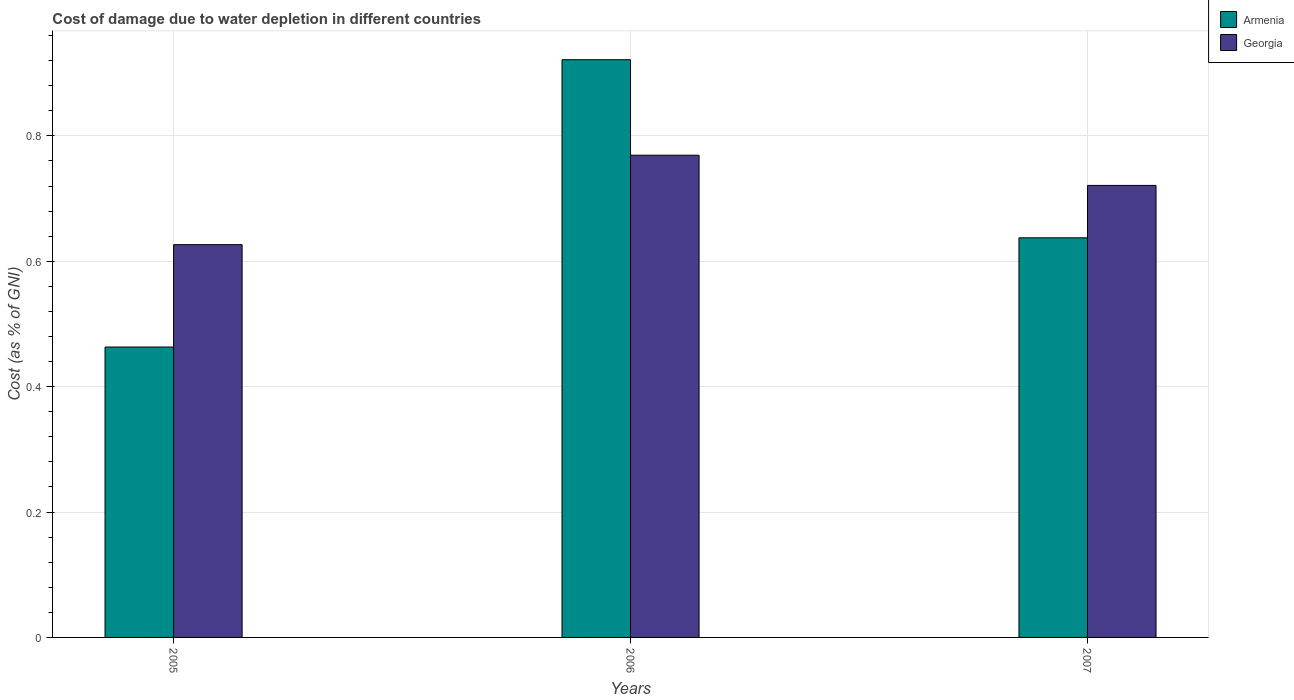How many groups of bars are there?
Your response must be concise. 3. Are the number of bars on each tick of the X-axis equal?
Offer a very short reply. Yes. How many bars are there on the 2nd tick from the left?
Your answer should be very brief. 2. What is the label of the 3rd group of bars from the left?
Offer a terse response. 2007. What is the cost of damage caused due to water depletion in Armenia in 2005?
Offer a very short reply. 0.46. Across all years, what is the maximum cost of damage caused due to water depletion in Georgia?
Ensure brevity in your answer.  0.77. Across all years, what is the minimum cost of damage caused due to water depletion in Georgia?
Offer a very short reply. 0.63. In which year was the cost of damage caused due to water depletion in Georgia maximum?
Keep it short and to the point. 2006. What is the total cost of damage caused due to water depletion in Georgia in the graph?
Your answer should be compact. 2.12. What is the difference between the cost of damage caused due to water depletion in Armenia in 2006 and that in 2007?
Keep it short and to the point. 0.28. What is the difference between the cost of damage caused due to water depletion in Georgia in 2005 and the cost of damage caused due to water depletion in Armenia in 2006?
Keep it short and to the point. -0.29. What is the average cost of damage caused due to water depletion in Georgia per year?
Make the answer very short. 0.71. In the year 2005, what is the difference between the cost of damage caused due to water depletion in Georgia and cost of damage caused due to water depletion in Armenia?
Make the answer very short. 0.16. In how many years, is the cost of damage caused due to water depletion in Armenia greater than 0.36 %?
Your response must be concise. 3. What is the ratio of the cost of damage caused due to water depletion in Georgia in 2005 to that in 2007?
Keep it short and to the point. 0.87. Is the cost of damage caused due to water depletion in Georgia in 2005 less than that in 2006?
Ensure brevity in your answer.  Yes. What is the difference between the highest and the second highest cost of damage caused due to water depletion in Georgia?
Your answer should be very brief. 0.05. What is the difference between the highest and the lowest cost of damage caused due to water depletion in Georgia?
Provide a succinct answer. 0.14. In how many years, is the cost of damage caused due to water depletion in Georgia greater than the average cost of damage caused due to water depletion in Georgia taken over all years?
Provide a short and direct response. 2. What does the 2nd bar from the left in 2007 represents?
Ensure brevity in your answer.  Georgia. What does the 1st bar from the right in 2005 represents?
Make the answer very short. Georgia. Does the graph contain grids?
Keep it short and to the point. Yes. Where does the legend appear in the graph?
Give a very brief answer. Top right. How are the legend labels stacked?
Provide a short and direct response. Vertical. What is the title of the graph?
Your response must be concise. Cost of damage due to water depletion in different countries. Does "El Salvador" appear as one of the legend labels in the graph?
Ensure brevity in your answer.  No. What is the label or title of the X-axis?
Provide a succinct answer. Years. What is the label or title of the Y-axis?
Your response must be concise. Cost (as % of GNI). What is the Cost (as % of GNI) of Armenia in 2005?
Give a very brief answer. 0.46. What is the Cost (as % of GNI) of Georgia in 2005?
Your answer should be very brief. 0.63. What is the Cost (as % of GNI) in Armenia in 2006?
Your answer should be compact. 0.92. What is the Cost (as % of GNI) in Georgia in 2006?
Keep it short and to the point. 0.77. What is the Cost (as % of GNI) in Armenia in 2007?
Make the answer very short. 0.64. What is the Cost (as % of GNI) of Georgia in 2007?
Ensure brevity in your answer.  0.72. Across all years, what is the maximum Cost (as % of GNI) in Armenia?
Provide a short and direct response. 0.92. Across all years, what is the maximum Cost (as % of GNI) of Georgia?
Give a very brief answer. 0.77. Across all years, what is the minimum Cost (as % of GNI) of Armenia?
Your answer should be compact. 0.46. Across all years, what is the minimum Cost (as % of GNI) in Georgia?
Give a very brief answer. 0.63. What is the total Cost (as % of GNI) of Armenia in the graph?
Offer a terse response. 2.02. What is the total Cost (as % of GNI) in Georgia in the graph?
Provide a succinct answer. 2.12. What is the difference between the Cost (as % of GNI) of Armenia in 2005 and that in 2006?
Your answer should be very brief. -0.46. What is the difference between the Cost (as % of GNI) in Georgia in 2005 and that in 2006?
Your answer should be compact. -0.14. What is the difference between the Cost (as % of GNI) in Armenia in 2005 and that in 2007?
Offer a very short reply. -0.17. What is the difference between the Cost (as % of GNI) in Georgia in 2005 and that in 2007?
Ensure brevity in your answer.  -0.09. What is the difference between the Cost (as % of GNI) of Armenia in 2006 and that in 2007?
Ensure brevity in your answer.  0.28. What is the difference between the Cost (as % of GNI) of Georgia in 2006 and that in 2007?
Your answer should be compact. 0.05. What is the difference between the Cost (as % of GNI) in Armenia in 2005 and the Cost (as % of GNI) in Georgia in 2006?
Your answer should be compact. -0.31. What is the difference between the Cost (as % of GNI) of Armenia in 2005 and the Cost (as % of GNI) of Georgia in 2007?
Offer a terse response. -0.26. What is the difference between the Cost (as % of GNI) in Armenia in 2006 and the Cost (as % of GNI) in Georgia in 2007?
Make the answer very short. 0.2. What is the average Cost (as % of GNI) of Armenia per year?
Your answer should be very brief. 0.67. What is the average Cost (as % of GNI) in Georgia per year?
Keep it short and to the point. 0.71. In the year 2005, what is the difference between the Cost (as % of GNI) in Armenia and Cost (as % of GNI) in Georgia?
Your response must be concise. -0.16. In the year 2006, what is the difference between the Cost (as % of GNI) in Armenia and Cost (as % of GNI) in Georgia?
Offer a very short reply. 0.15. In the year 2007, what is the difference between the Cost (as % of GNI) of Armenia and Cost (as % of GNI) of Georgia?
Give a very brief answer. -0.08. What is the ratio of the Cost (as % of GNI) in Armenia in 2005 to that in 2006?
Keep it short and to the point. 0.5. What is the ratio of the Cost (as % of GNI) in Georgia in 2005 to that in 2006?
Give a very brief answer. 0.81. What is the ratio of the Cost (as % of GNI) of Armenia in 2005 to that in 2007?
Offer a very short reply. 0.73. What is the ratio of the Cost (as % of GNI) of Georgia in 2005 to that in 2007?
Make the answer very short. 0.87. What is the ratio of the Cost (as % of GNI) of Armenia in 2006 to that in 2007?
Ensure brevity in your answer.  1.45. What is the ratio of the Cost (as % of GNI) of Georgia in 2006 to that in 2007?
Provide a short and direct response. 1.07. What is the difference between the highest and the second highest Cost (as % of GNI) in Armenia?
Give a very brief answer. 0.28. What is the difference between the highest and the second highest Cost (as % of GNI) in Georgia?
Offer a very short reply. 0.05. What is the difference between the highest and the lowest Cost (as % of GNI) of Armenia?
Your answer should be compact. 0.46. What is the difference between the highest and the lowest Cost (as % of GNI) in Georgia?
Your answer should be compact. 0.14. 